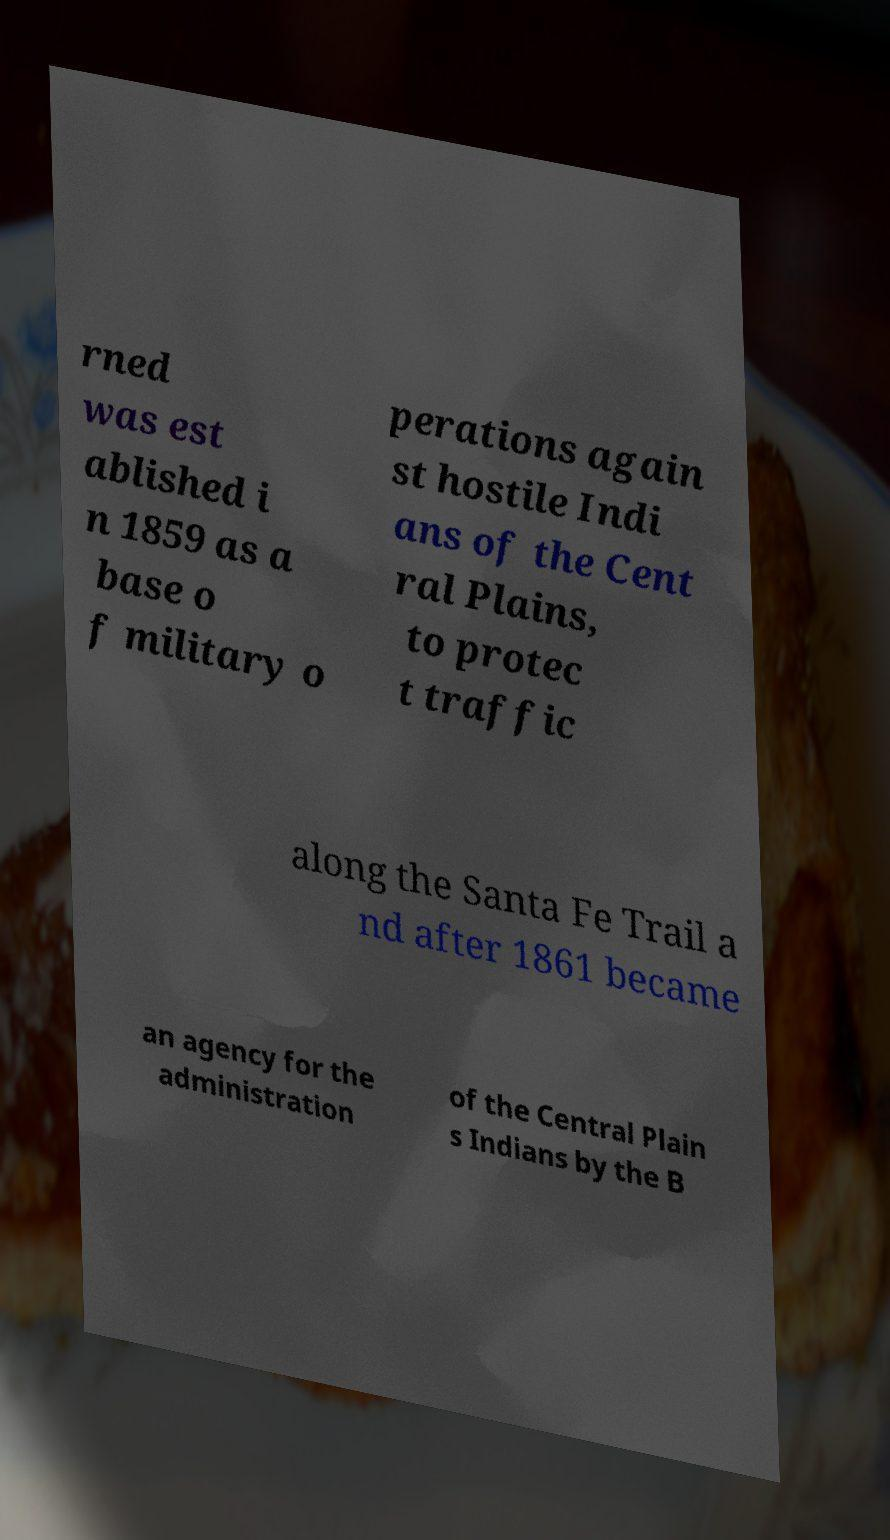Could you extract and type out the text from this image? rned was est ablished i n 1859 as a base o f military o perations again st hostile Indi ans of the Cent ral Plains, to protec t traffic along the Santa Fe Trail a nd after 1861 became an agency for the administration of the Central Plain s Indians by the B 